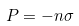<formula> <loc_0><loc_0><loc_500><loc_500>P = - n \sigma</formula> 